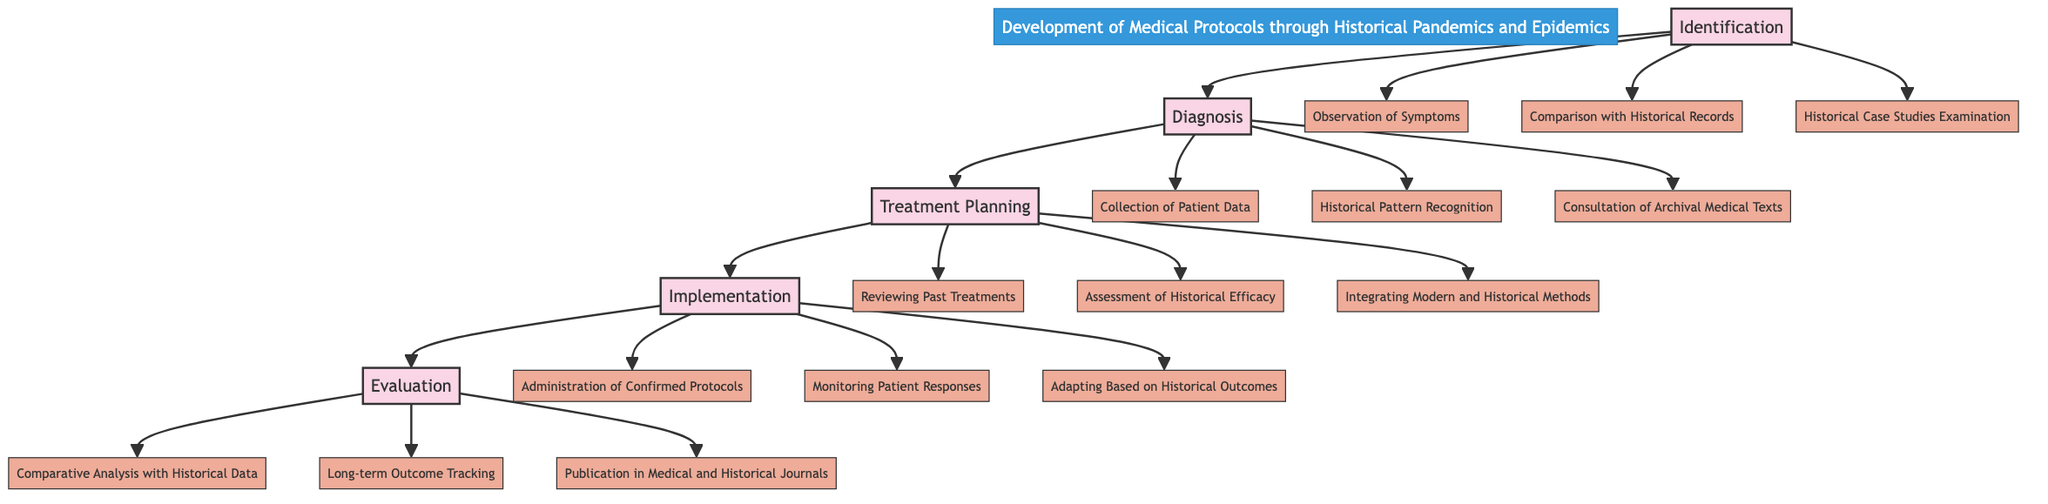What are the components of the Identification stage? The Identification stage consists of three components: Observation of Symptoms, Comparison with Historical Records, and Historical Case Studies Examination. By referring to the diagram, we can see the specific components listed under this stage.
Answer: Observation of Symptoms, Comparison with Historical Records, Historical Case Studies Examination Which stage follows Diagnosis? In the flow of the Clinical Pathway, the stage that follows Diagnosis is Treatment Planning. This can be determined by looking at the sequential progression of the stages depicted in the diagram.
Answer: Treatment Planning How many components does the Implementation stage have? The Implementation stage has three components: Administration of Confirmed Protocols, Monitoring Patient Responses, and Adapting Based on Historical Outcomes. Counting the components beneath this stage in the diagram provides the answer.
Answer: 3 Which component is included in both the Diagnosis and Evaluation stages? The component that is included in both the Diagnosis and Evaluation stages is Historical Pattern Recognition. By examining the components of each stage, we find Historical Pattern Recognition listed under Diagnosis and inferred application in Evaluation through comparative analysis.
Answer: Historical Pattern Recognition What is the last stage in the diagram? The last stage in the Clinical Pathway diagram is Evaluation. This can be identified by following the arrows through the stages until reaching the final point in the flow.
Answer: Evaluation Which stage includes reviewing past treatments? Reviewing Past Treatments is a component of the Treatment Planning stage. This can be found clearly listed in the Treatment Planning section of the diagram.
Answer: Treatment Planning What is the primary purpose of the Evaluation stage? The primary purpose of the Evaluation stage is to perform Comparative Analysis with Historical Data. This can be deduced by analyzing the components listed under the Evaluation stage in the diagram.
Answer: Comparative Analysis with Historical Data 